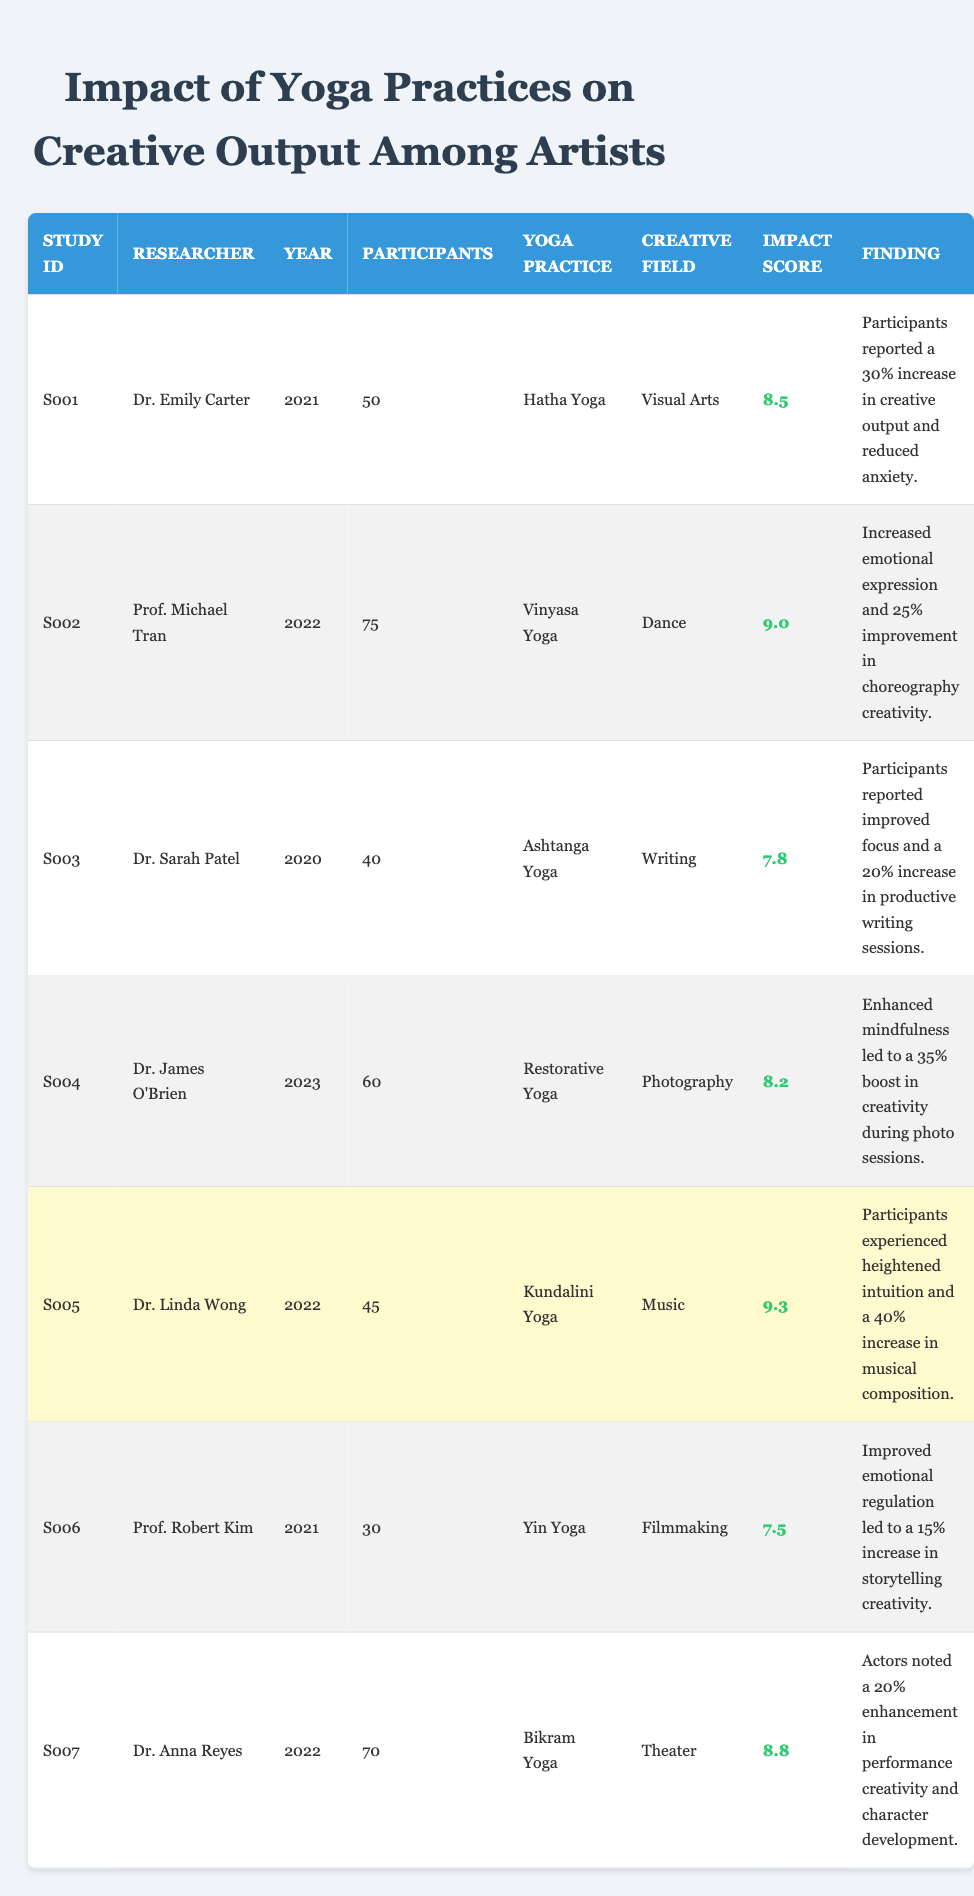What is the highest impact score recorded in the studies? The highest impact score is found in the study by Dr. Linda Wong with an impact score of 9.3.
Answer: 9.3 Which yoga practice corresponds to the lowest impact score? The lowest impact score is associated with Yin Yoga, which has an impact score of 7.5.
Answer: 7.5 How many participants were involved in the study on Vinyasa Yoga? The study on Vinyasa Yoga involved 75 participants as noted in the table.
Answer: 75 What is the average impact score across all studies? To calculate the average impact score, sum the scores (8.5 + 9.0 + 7.8 + 8.2 + 9.3 + 7.5 + 8.8) = 59.1. There are 7 studies, thus the average is 59.1/7 = 8.43.
Answer: 8.43 Did Hatha Yoga lead to an increase in creative output? Yes, the finding states there was a 30% increase in creative output among participants practicing Hatha Yoga.
Answer: Yes What is the percentage improvement in creativity reported by participants in the study involving Restorative Yoga? The study on Restorative Yoga reported a 35% boost in creativity during photo sessions.
Answer: 35% Among the studies listed, which creative field reported the highest intuition increase and by what percentage? The study by Dr. Linda Wong on Kundalini Yoga reported a 40% increase in musical composition due to heightened intuition.
Answer: 40% Is there a significant difference between the impact scores of Ashtanga Yoga and Yin Yoga? Yes, Ashtanga Yoga has an impact score of 7.8, while Yin Yoga has a score of 7.5, indicating a difference of 0.3.
Answer: Yes Which yoga practice had the largest number of participants and what was the study ID? Vinyasa Yoga had the largest number of participants (75). The study ID is S002.
Answer: S002 How many studies involved yoga practices that resulted in emotional expression improvements? There are two studies: Vinyasa Yoga (S002) and Bikram Yoga (S007) where emotional expression improvements were noted.
Answer: 2 